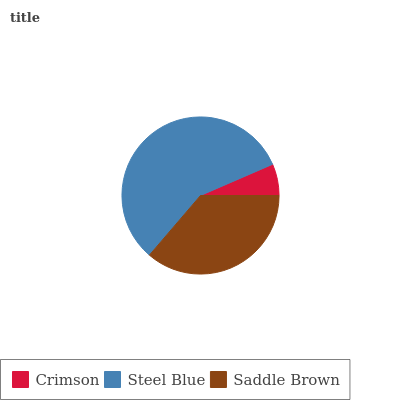Is Crimson the minimum?
Answer yes or no. Yes. Is Steel Blue the maximum?
Answer yes or no. Yes. Is Saddle Brown the minimum?
Answer yes or no. No. Is Saddle Brown the maximum?
Answer yes or no. No. Is Steel Blue greater than Saddle Brown?
Answer yes or no. Yes. Is Saddle Brown less than Steel Blue?
Answer yes or no. Yes. Is Saddle Brown greater than Steel Blue?
Answer yes or no. No. Is Steel Blue less than Saddle Brown?
Answer yes or no. No. Is Saddle Brown the high median?
Answer yes or no. Yes. Is Saddle Brown the low median?
Answer yes or no. Yes. Is Steel Blue the high median?
Answer yes or no. No. Is Steel Blue the low median?
Answer yes or no. No. 